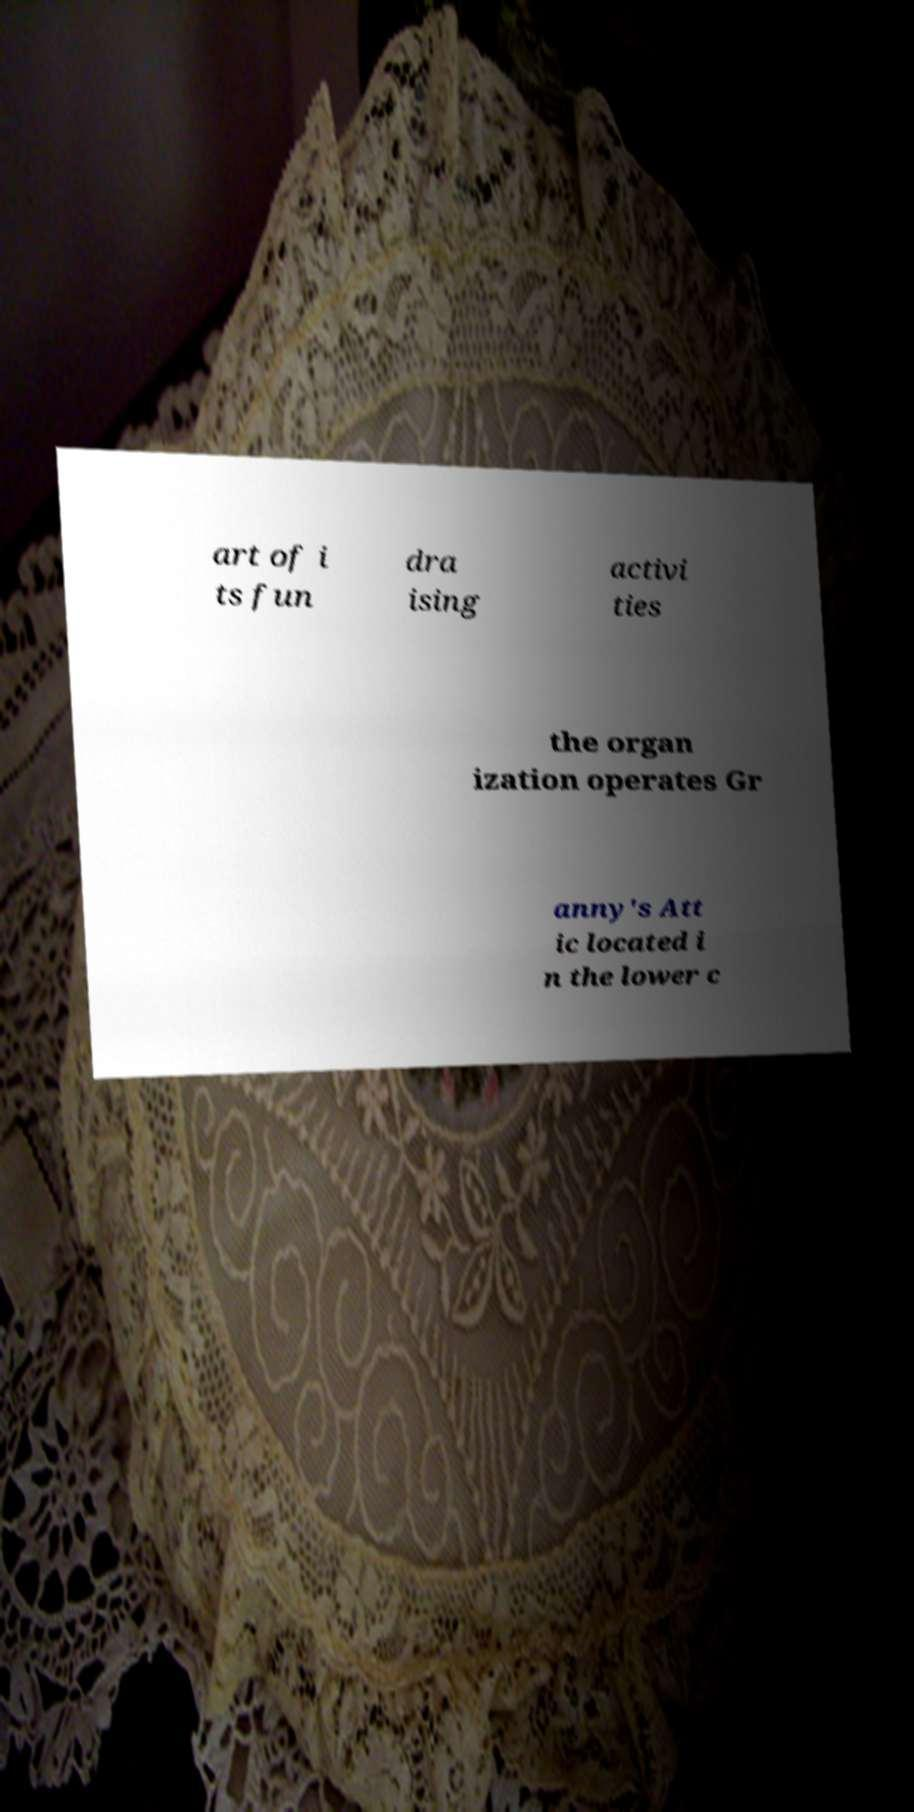What messages or text are displayed in this image? I need them in a readable, typed format. art of i ts fun dra ising activi ties the organ ization operates Gr anny's Att ic located i n the lower c 